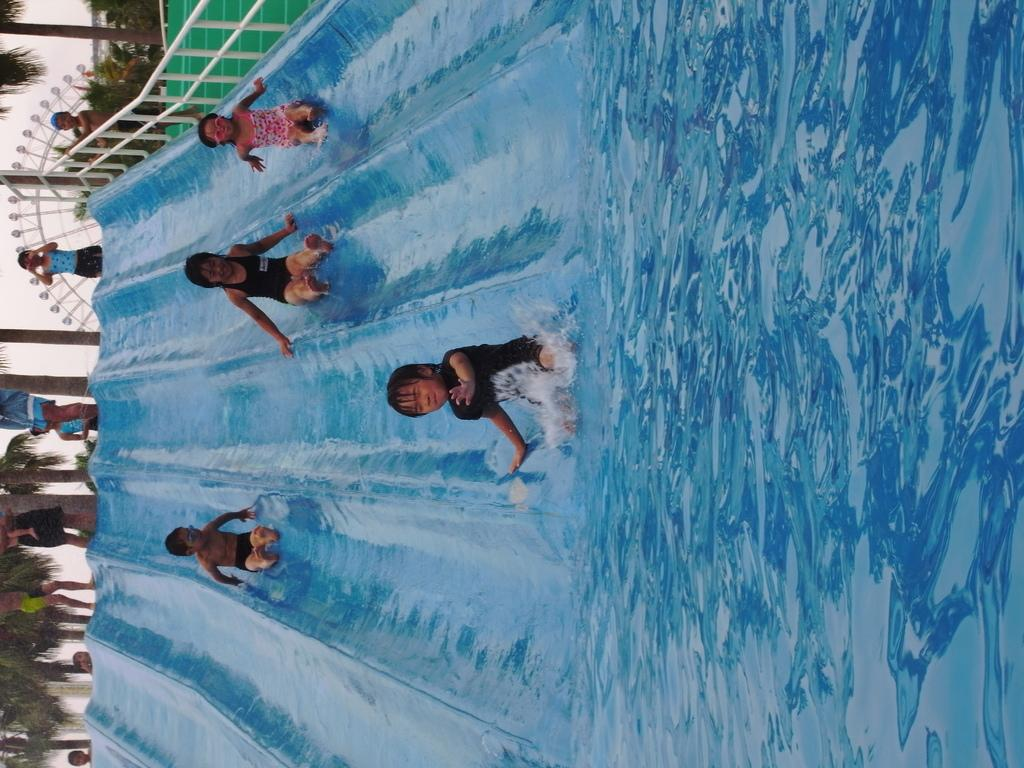What type of recreational facility is depicted in the image? There are water slides in the image, which suggests it is a water park or similar facility. Can you describe the people in the image? There are people in the image, but their specific actions or activities cannot be determined from the provided facts. What type of barrier is present in the image? There is a fence in the image, which may serve as a safety or boundary feature. What type of vegetation is present in the image? There are plants and trees in the image, which contribute to the overall landscape and setting. What is visible in the sky in the image? The sky is visible in the image, but no specific weather conditions or celestial bodies can be determined from the provided facts. Where is the fireman using the pipe to smash the water slides in the image? There is no fireman or pipe present in the image, and the water slides are not being smashed. 